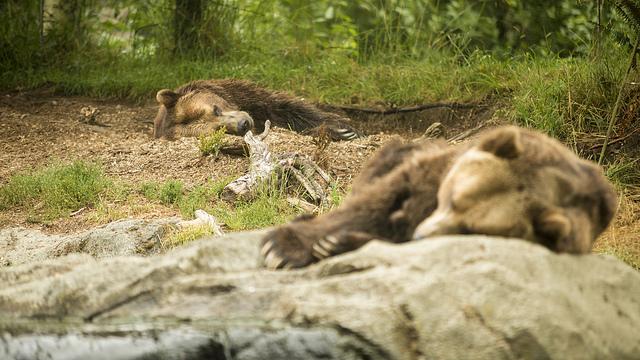How many animals are shown?
Keep it brief. 2. Are these bears hunting?
Answer briefly. No. Who is laying on the ground?
Quick response, please. Bears. Are they in a home?
Quick response, please. No. How many bears in the tree?
Short answer required. 0. 